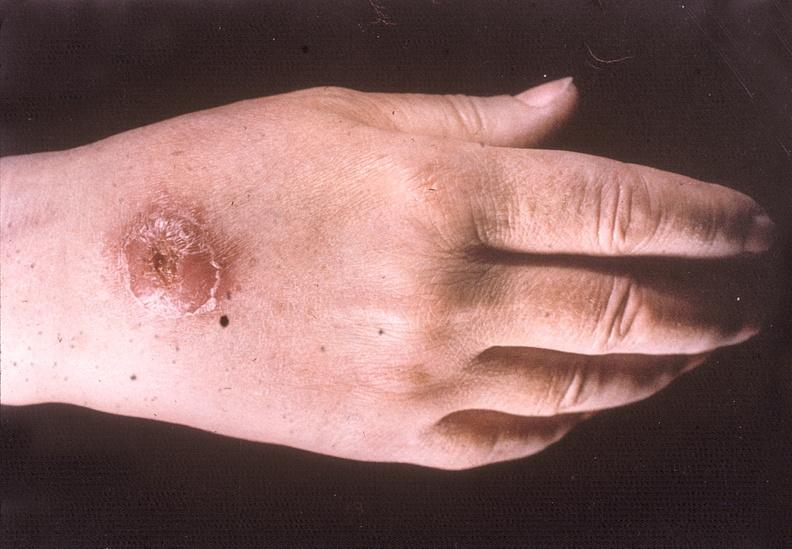re good example tastefully shown with face out of picture and genitalia present?
Answer the question using a single word or phrase. No 